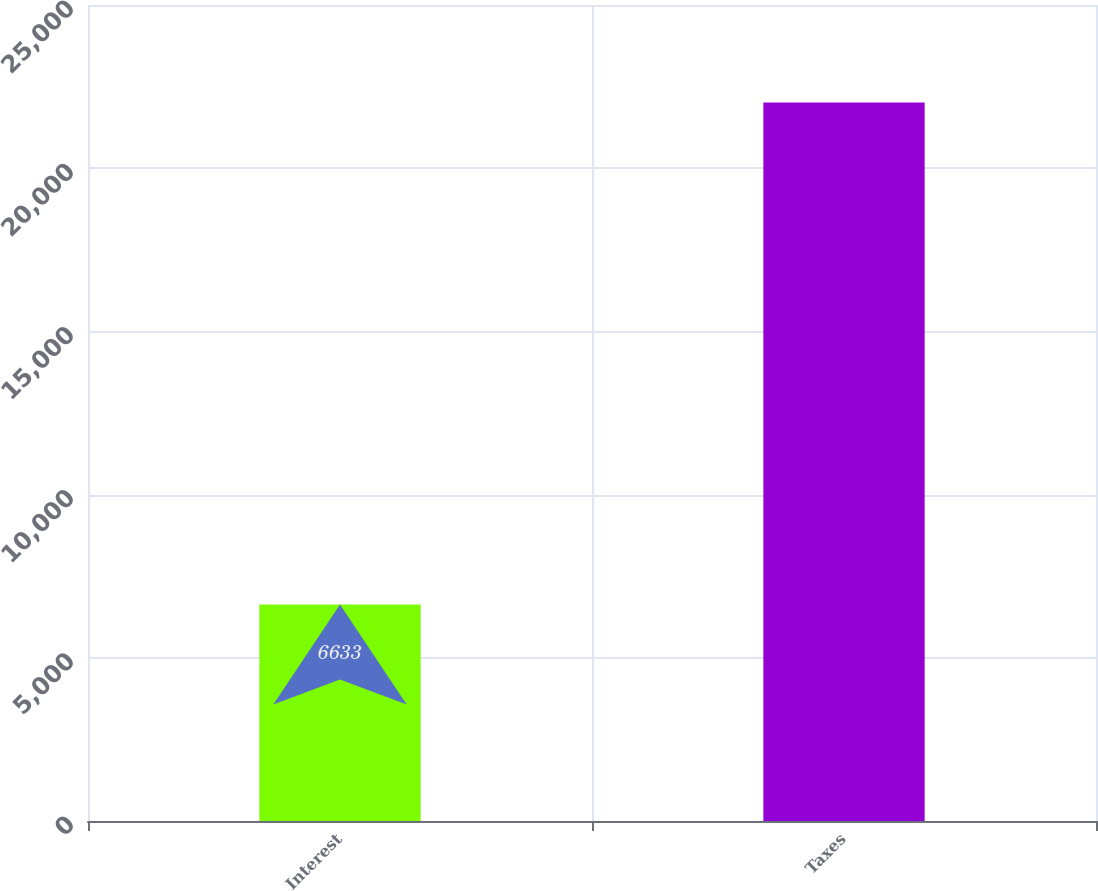<chart> <loc_0><loc_0><loc_500><loc_500><bar_chart><fcel>Interest<fcel>Taxes<nl><fcel>6633<fcel>22013<nl></chart> 